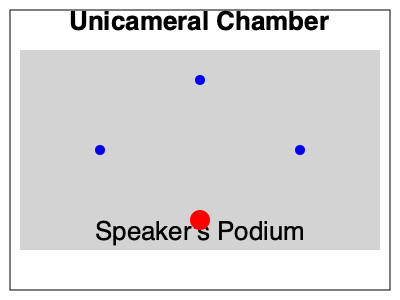Based on the floor plan of Nebraska's Unicameral Legislature chamber, which seat position (A, B, or C) is likely to be assigned to a senior member with the most seniority? To determine which seat is likely assigned to a senior member with the most seniority, we need to consider the following factors:

1. Proximity to the Speaker: Senior members are often seated closer to the Speaker's podium for easier communication and participation in debates.

2. Centrality: Influential members are typically seated in central positions for better visibility and to facilitate interaction with colleagues.

3. Traditional seating arrangements: In many legislatures, senior members are given preference for seats closer to the center aisle or the front of the chamber.

Analyzing the floor plan:

- Seat A is close to the Speaker but off to the side.
- Seat B is also close to the Speaker but on the opposite side.
- Seat C is centrally located and closer to the front of the chamber.

Given these considerations, Seat C is the most likely position for a senior member with the most seniority because:

1. It is centrally located, providing good visibility and easy access to the floor for speeches.
2. It is closer to the front of the chamber, which is traditionally reserved for more senior members.
3. While not the closest to the Speaker, it still offers a good position for interaction and participation in legislative proceedings.
Answer: C 